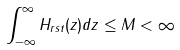Convert formula to latex. <formula><loc_0><loc_0><loc_500><loc_500>\int _ { - \infty } ^ { \infty } H _ { r s t } ( z ) d z \leq M < \infty</formula> 